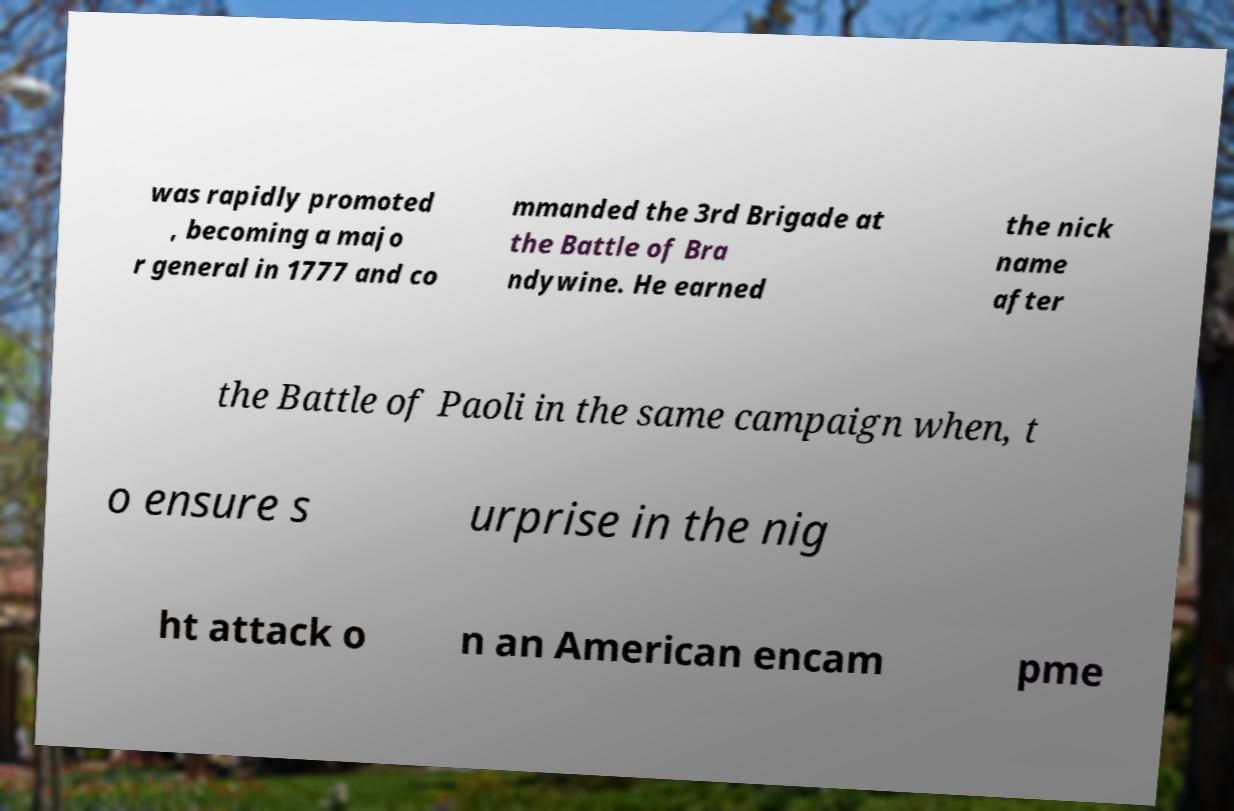Please identify and transcribe the text found in this image. was rapidly promoted , becoming a majo r general in 1777 and co mmanded the 3rd Brigade at the Battle of Bra ndywine. He earned the nick name after the Battle of Paoli in the same campaign when, t o ensure s urprise in the nig ht attack o n an American encam pme 